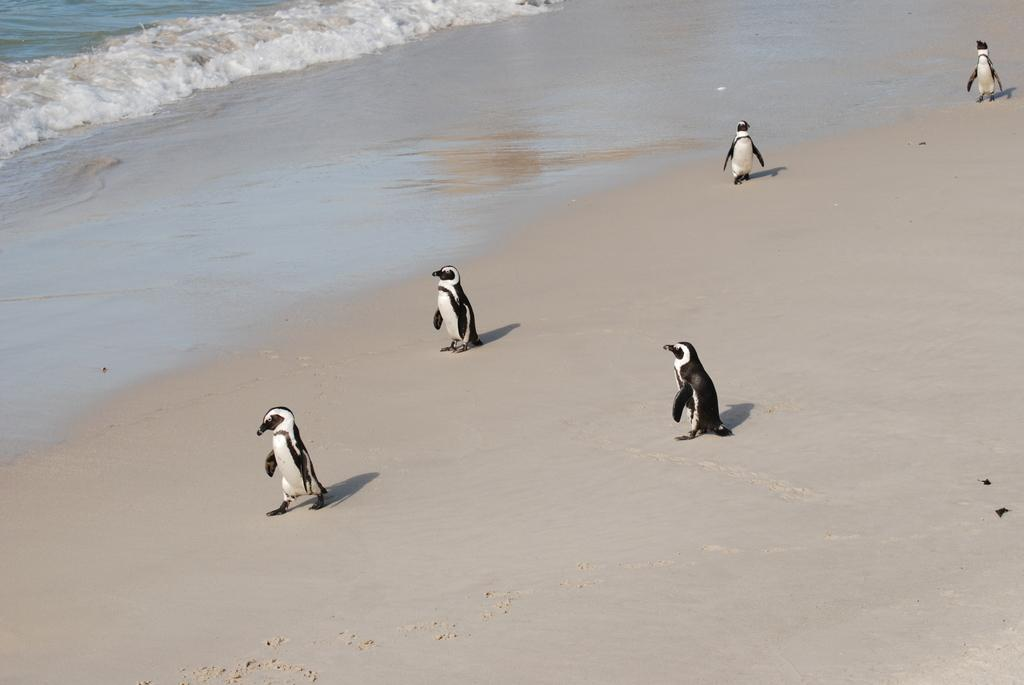What type of terrain is visible in the image? There is sand in the image. How many penguins can be seen on the sand? There are 5 penguins on the sand. What can be seen in the background of the image? There is water visible in the background of the image. What side of the penguins is coughing in the image? Penguins do not have the ability to cough, and there is no indication of any penguin exhibiting such behavior in the image. --- Facts: 1. There is a person holding a camera in the image. 2. The person is wearing a hat. 3. There is a building in the background of the image. 4. The person is standing on a bridge. Absurd Topics: dance, rainbow, parrot Conversation: What is the person in the image holding? The person in the image is holding a camera. What type of headwear is the person wearing? The person is wearing a hat. What can be seen in the background of the image? There is a building in the background of the image. Where is the person standing in the image? The person is standing on a bridge. Reasoning: Let's think step by step in order to produce the conversation. We start by identifying the main subject in the image, which is the person holding a camera. Then, we expand the conversation to include other details about the person, such as their headwear and location. Finally, we describe the background of the image, which includes a building. Each question is designed to elicit a specific detail about the image that is known from the provided facts. Absurd Question/Answer: What type of dance is the person performing on the bridge in the image? There is no indication of the person performing any dance in the image. 